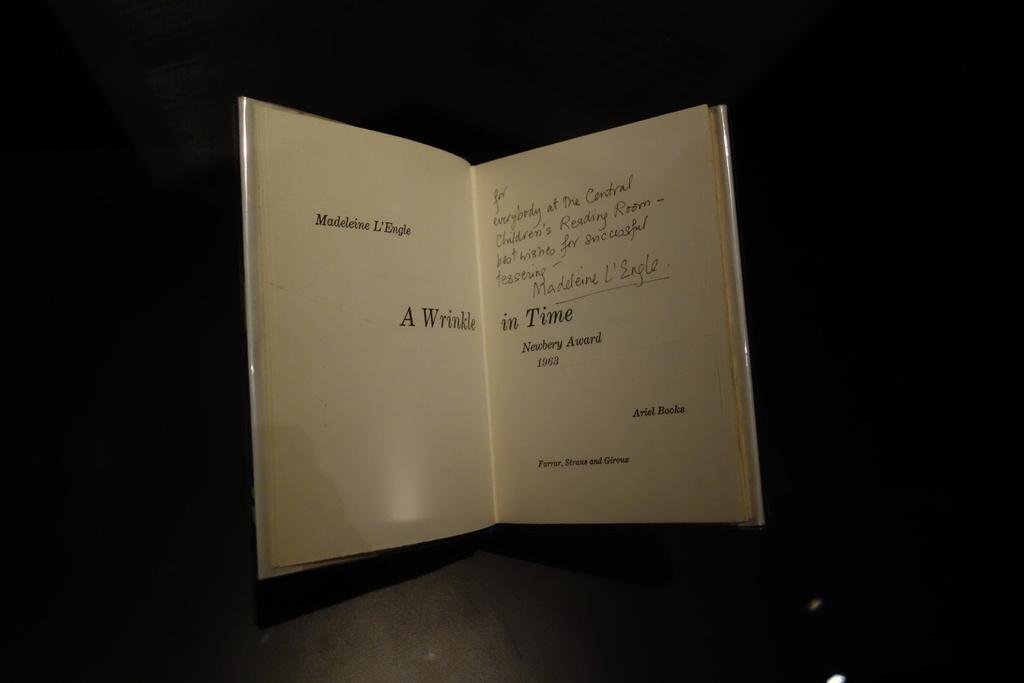Who signed this?
Make the answer very short. Madeleine l'engle. What is the title in the middle?
Your response must be concise. A wrinkle in time. 